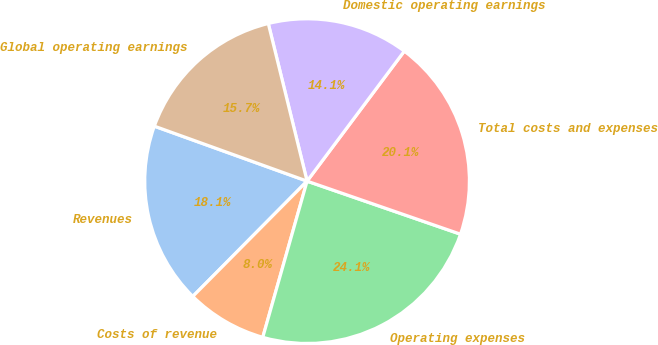Convert chart to OTSL. <chart><loc_0><loc_0><loc_500><loc_500><pie_chart><fcel>Revenues<fcel>Costs of revenue<fcel>Operating expenses<fcel>Total costs and expenses<fcel>Domestic operating earnings<fcel>Global operating earnings<nl><fcel>18.07%<fcel>8.03%<fcel>24.1%<fcel>20.08%<fcel>14.06%<fcel>15.66%<nl></chart> 